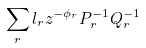Convert formula to latex. <formula><loc_0><loc_0><loc_500><loc_500>\sum _ { r } l _ { r } z ^ { - \phi _ { r } } P _ { r } ^ { - 1 } Q _ { r } ^ { - 1 }</formula> 